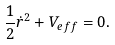Convert formula to latex. <formula><loc_0><loc_0><loc_500><loc_500>\frac { 1 } { 2 } \dot { r } ^ { 2 } + V _ { e f f } = 0 .</formula> 